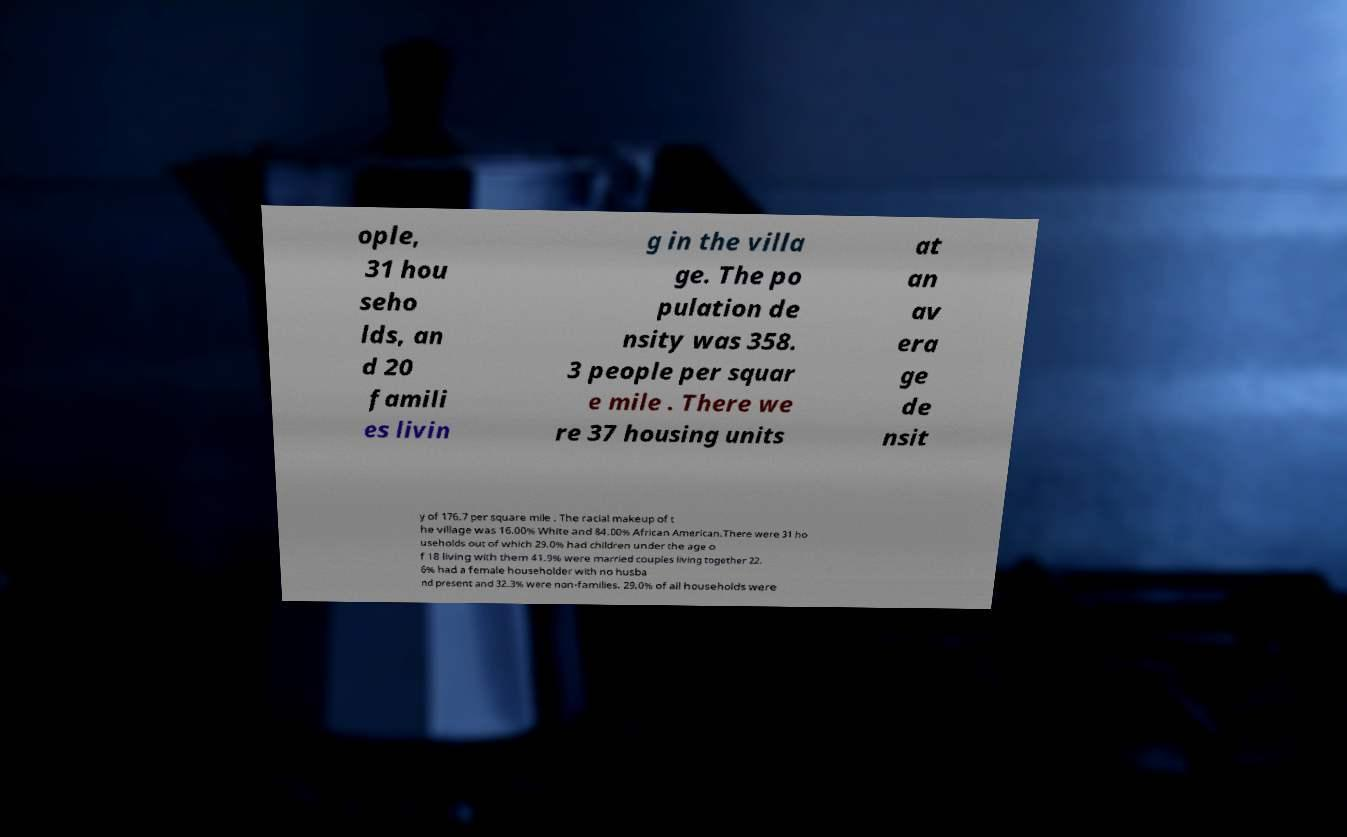I need the written content from this picture converted into text. Can you do that? ople, 31 hou seho lds, an d 20 famili es livin g in the villa ge. The po pulation de nsity was 358. 3 people per squar e mile . There we re 37 housing units at an av era ge de nsit y of 176.7 per square mile . The racial makeup of t he village was 16.00% White and 84.00% African American.There were 31 ho useholds out of which 29.0% had children under the age o f 18 living with them 41.9% were married couples living together 22. 6% had a female householder with no husba nd present and 32.3% were non-families. 29.0% of all households were 